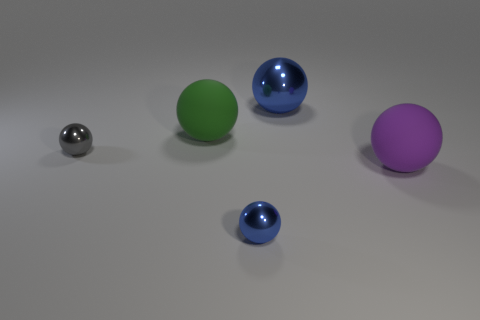Subtract all green balls. How many balls are left? 4 Subtract all tiny gray balls. How many balls are left? 4 Subtract all yellow balls. Subtract all gray cylinders. How many balls are left? 5 Add 3 large metallic things. How many objects exist? 8 Subtract all large brown metal spheres. Subtract all shiny things. How many objects are left? 2 Add 2 small spheres. How many small spheres are left? 4 Add 3 large gray blocks. How many large gray blocks exist? 3 Subtract 0 cyan blocks. How many objects are left? 5 